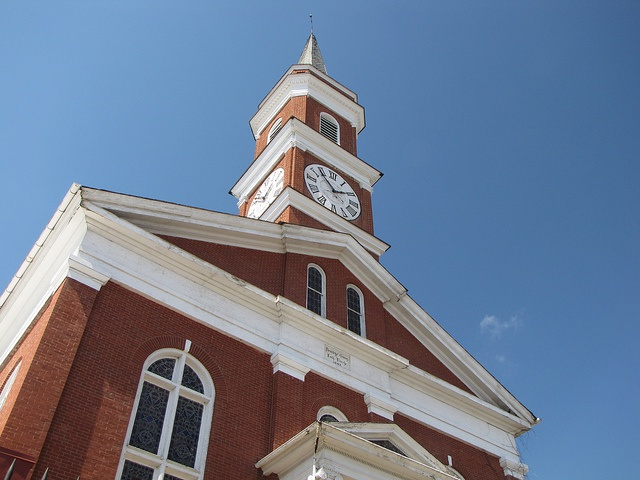Describe the objects in this image and their specific colors. I can see clock in darkgray, gray, and lightgray tones and clock in darkgray, white, and gray tones in this image. 